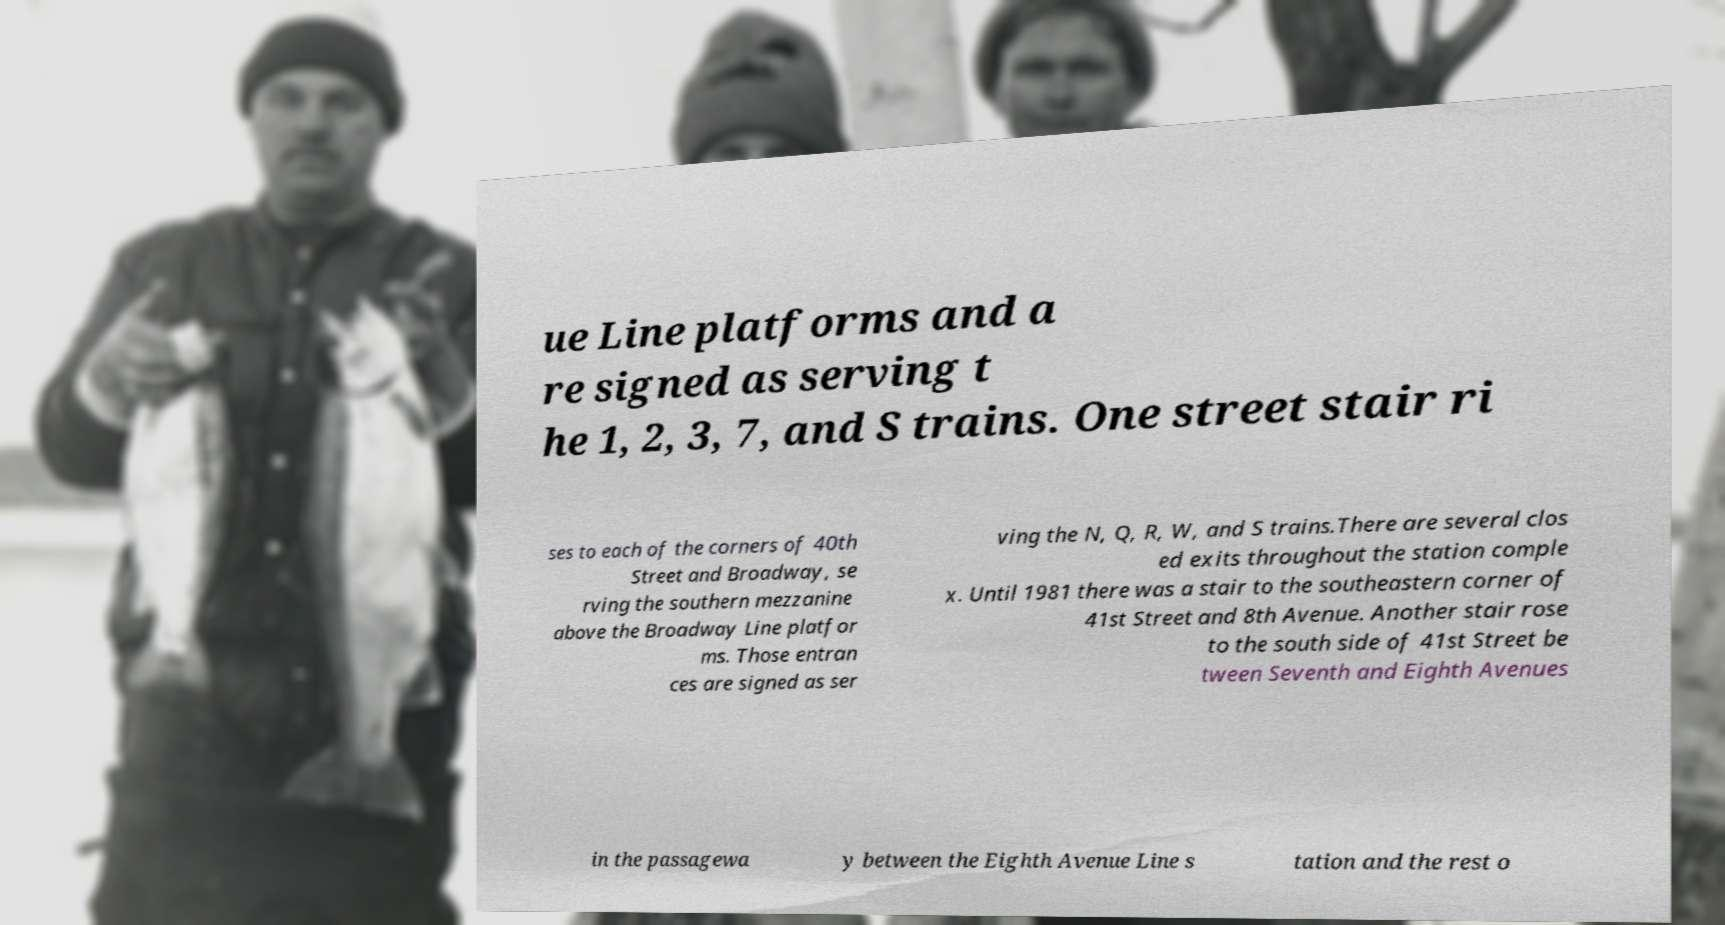I need the written content from this picture converted into text. Can you do that? ue Line platforms and a re signed as serving t he 1, 2, 3, 7, and S trains. One street stair ri ses to each of the corners of 40th Street and Broadway, se rving the southern mezzanine above the Broadway Line platfor ms. Those entran ces are signed as ser ving the N, Q, R, W, and S trains.There are several clos ed exits throughout the station comple x. Until 1981 there was a stair to the southeastern corner of 41st Street and 8th Avenue. Another stair rose to the south side of 41st Street be tween Seventh and Eighth Avenues in the passagewa y between the Eighth Avenue Line s tation and the rest o 